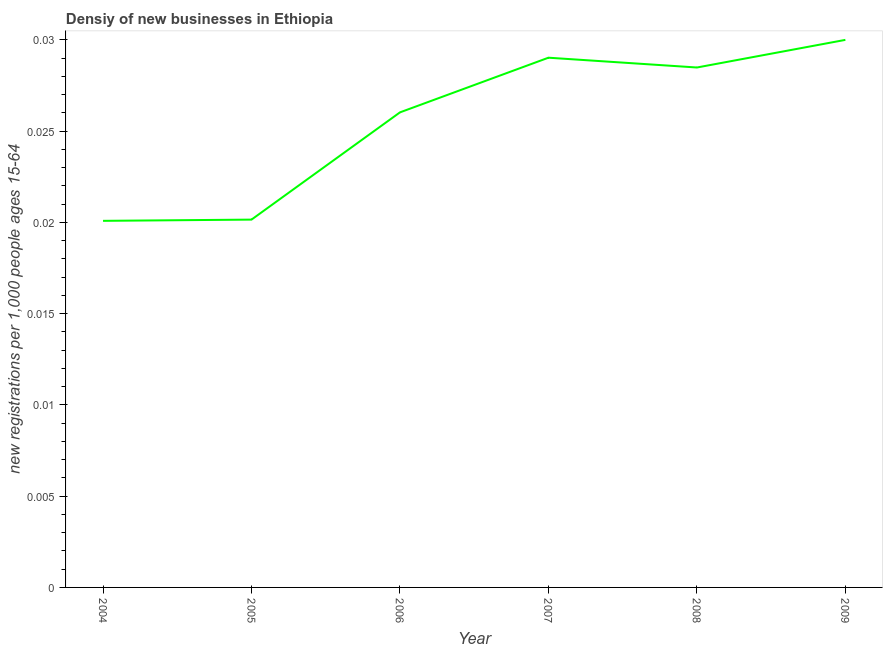What is the density of new business in 2009?
Make the answer very short. 0.03. Across all years, what is the minimum density of new business?
Offer a very short reply. 0.02. What is the sum of the density of new business?
Give a very brief answer. 0.15. What is the difference between the density of new business in 2004 and 2007?
Provide a short and direct response. -0.01. What is the average density of new business per year?
Offer a very short reply. 0.03. What is the median density of new business?
Offer a very short reply. 0.03. Do a majority of the years between 2009 and 2007 (inclusive) have density of new business greater than 0.022 ?
Give a very brief answer. No. What is the ratio of the density of new business in 2004 to that in 2006?
Provide a succinct answer. 0.77. Is the density of new business in 2007 less than that in 2009?
Give a very brief answer. Yes. What is the difference between the highest and the second highest density of new business?
Make the answer very short. 0. What is the difference between the highest and the lowest density of new business?
Make the answer very short. 0.01. In how many years, is the density of new business greater than the average density of new business taken over all years?
Your answer should be compact. 4. Does the density of new business monotonically increase over the years?
Offer a terse response. No. What is the difference between two consecutive major ticks on the Y-axis?
Offer a terse response. 0.01. Are the values on the major ticks of Y-axis written in scientific E-notation?
Provide a short and direct response. No. Does the graph contain any zero values?
Offer a very short reply. No. What is the title of the graph?
Give a very brief answer. Densiy of new businesses in Ethiopia. What is the label or title of the Y-axis?
Keep it short and to the point. New registrations per 1,0 people ages 15-64. What is the new registrations per 1,000 people ages 15-64 of 2004?
Ensure brevity in your answer.  0.02. What is the new registrations per 1,000 people ages 15-64 in 2005?
Provide a short and direct response. 0.02. What is the new registrations per 1,000 people ages 15-64 of 2006?
Ensure brevity in your answer.  0.03. What is the new registrations per 1,000 people ages 15-64 of 2007?
Give a very brief answer. 0.03. What is the new registrations per 1,000 people ages 15-64 in 2008?
Offer a very short reply. 0.03. What is the difference between the new registrations per 1,000 people ages 15-64 in 2004 and 2005?
Keep it short and to the point. -7e-5. What is the difference between the new registrations per 1,000 people ages 15-64 in 2004 and 2006?
Provide a succinct answer. -0.01. What is the difference between the new registrations per 1,000 people ages 15-64 in 2004 and 2007?
Keep it short and to the point. -0.01. What is the difference between the new registrations per 1,000 people ages 15-64 in 2004 and 2008?
Provide a succinct answer. -0.01. What is the difference between the new registrations per 1,000 people ages 15-64 in 2004 and 2009?
Make the answer very short. -0.01. What is the difference between the new registrations per 1,000 people ages 15-64 in 2005 and 2006?
Keep it short and to the point. -0.01. What is the difference between the new registrations per 1,000 people ages 15-64 in 2005 and 2007?
Offer a terse response. -0.01. What is the difference between the new registrations per 1,000 people ages 15-64 in 2005 and 2008?
Give a very brief answer. -0.01. What is the difference between the new registrations per 1,000 people ages 15-64 in 2005 and 2009?
Provide a short and direct response. -0.01. What is the difference between the new registrations per 1,000 people ages 15-64 in 2006 and 2007?
Give a very brief answer. -0. What is the difference between the new registrations per 1,000 people ages 15-64 in 2006 and 2008?
Provide a short and direct response. -0. What is the difference between the new registrations per 1,000 people ages 15-64 in 2006 and 2009?
Give a very brief answer. -0. What is the difference between the new registrations per 1,000 people ages 15-64 in 2007 and 2008?
Keep it short and to the point. 0. What is the difference between the new registrations per 1,000 people ages 15-64 in 2007 and 2009?
Make the answer very short. -0. What is the difference between the new registrations per 1,000 people ages 15-64 in 2008 and 2009?
Your response must be concise. -0. What is the ratio of the new registrations per 1,000 people ages 15-64 in 2004 to that in 2005?
Keep it short and to the point. 1. What is the ratio of the new registrations per 1,000 people ages 15-64 in 2004 to that in 2006?
Your answer should be very brief. 0.77. What is the ratio of the new registrations per 1,000 people ages 15-64 in 2004 to that in 2007?
Give a very brief answer. 0.69. What is the ratio of the new registrations per 1,000 people ages 15-64 in 2004 to that in 2008?
Give a very brief answer. 0.7. What is the ratio of the new registrations per 1,000 people ages 15-64 in 2004 to that in 2009?
Keep it short and to the point. 0.67. What is the ratio of the new registrations per 1,000 people ages 15-64 in 2005 to that in 2006?
Give a very brief answer. 0.77. What is the ratio of the new registrations per 1,000 people ages 15-64 in 2005 to that in 2007?
Ensure brevity in your answer.  0.69. What is the ratio of the new registrations per 1,000 people ages 15-64 in 2005 to that in 2008?
Your response must be concise. 0.71. What is the ratio of the new registrations per 1,000 people ages 15-64 in 2005 to that in 2009?
Give a very brief answer. 0.67. What is the ratio of the new registrations per 1,000 people ages 15-64 in 2006 to that in 2007?
Keep it short and to the point. 0.9. What is the ratio of the new registrations per 1,000 people ages 15-64 in 2006 to that in 2008?
Keep it short and to the point. 0.91. What is the ratio of the new registrations per 1,000 people ages 15-64 in 2006 to that in 2009?
Your response must be concise. 0.87. What is the ratio of the new registrations per 1,000 people ages 15-64 in 2007 to that in 2008?
Keep it short and to the point. 1.02. What is the ratio of the new registrations per 1,000 people ages 15-64 in 2007 to that in 2009?
Give a very brief answer. 0.97. 